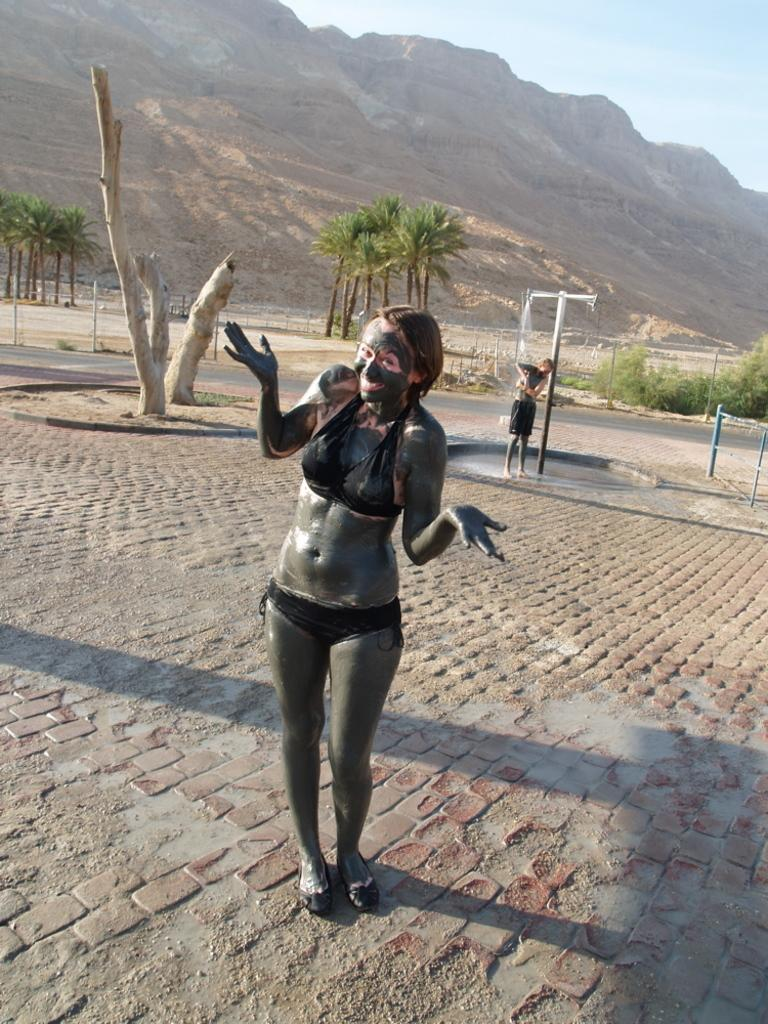How many people are present in the image? There are two people standing in the image. What can be seen in the background of the image? Trees and mountains are visible in the image. What is the color of the trees in the image? The trees are green in color. What is the color of the sky in the image? The sky is blue in color. What type of sweater is the woman wearing in the image? There is no woman or sweater present in the image. How many women are visible in the image? There are no women present in the image; there are only two people, both of whom are men or boys. 